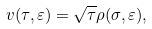Convert formula to latex. <formula><loc_0><loc_0><loc_500><loc_500>v ( \tau , \varepsilon ) = \sqrt { \tau } \rho ( \sigma , \varepsilon ) ,</formula> 